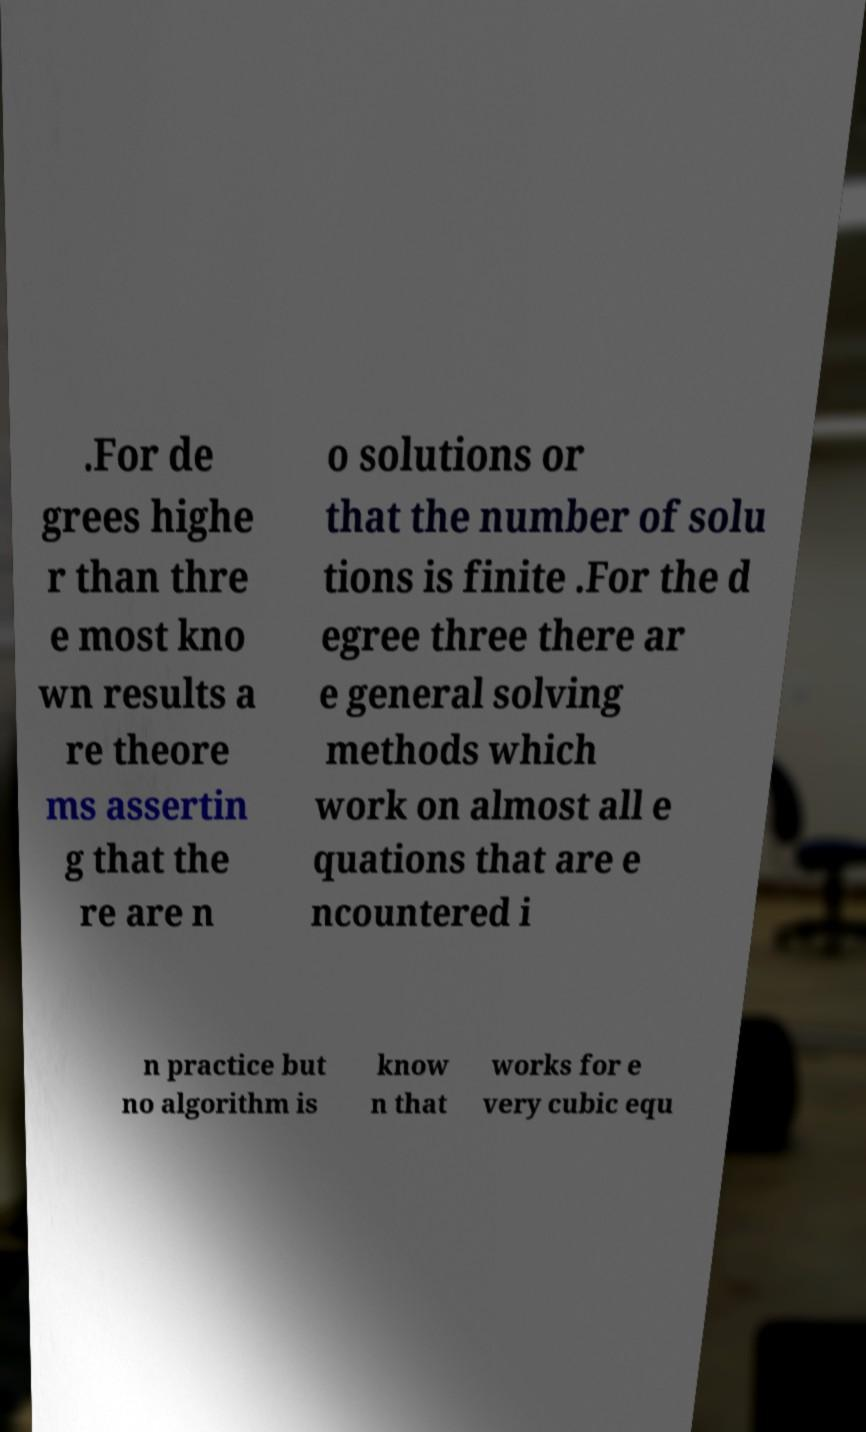Please read and relay the text visible in this image. What does it say? .For de grees highe r than thre e most kno wn results a re theore ms assertin g that the re are n o solutions or that the number of solu tions is finite .For the d egree three there ar e general solving methods which work on almost all e quations that are e ncountered i n practice but no algorithm is know n that works for e very cubic equ 